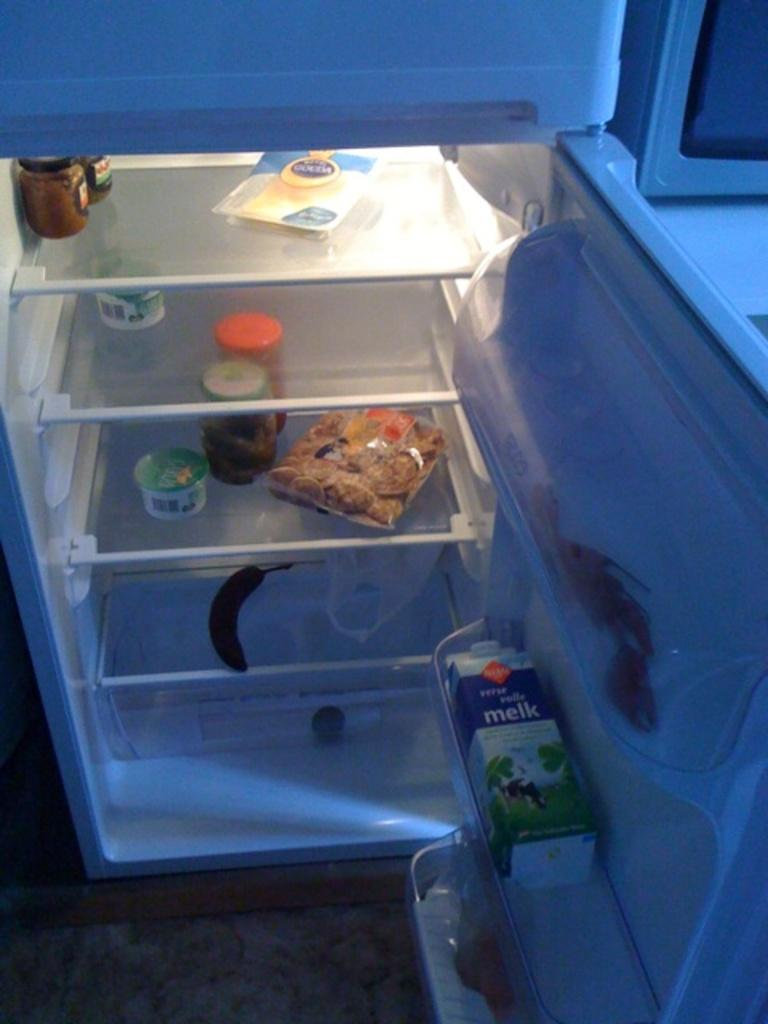Provide a one-sentence caption for the provided image. A refrigerator with Melk sitting on the door. 